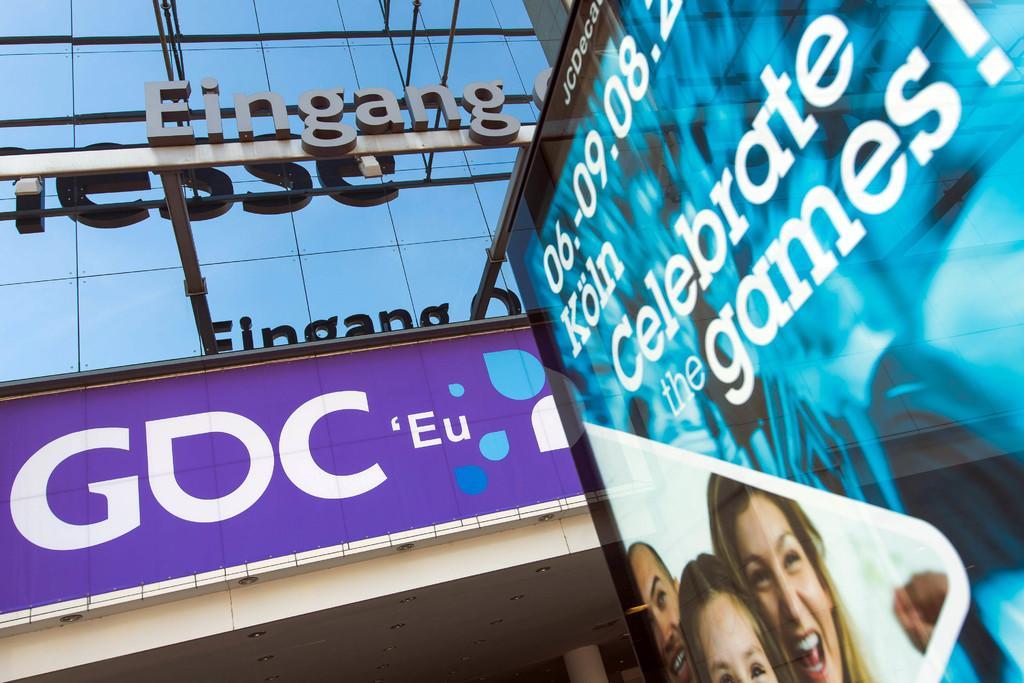How would you summarize this image in a sentence or two? In the picture we can see a building wall with full of glasses and a name on it EINGANG and near to it, we can see a hoarding with some advertisement on it. 